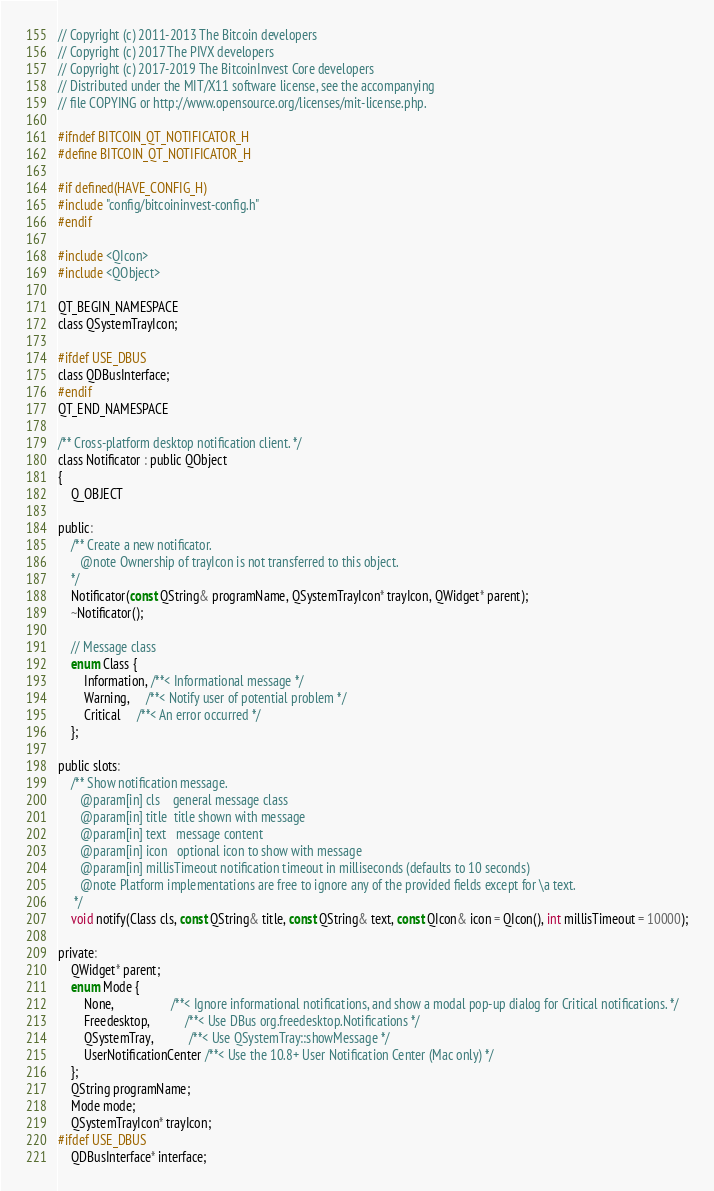Convert code to text. <code><loc_0><loc_0><loc_500><loc_500><_C_>// Copyright (c) 2011-2013 The Bitcoin developers
// Copyright (c) 2017 The PIVX developers
// Copyright (c) 2017-2019 The BitcoinInvest Core developers
// Distributed under the MIT/X11 software license, see the accompanying
// file COPYING or http://www.opensource.org/licenses/mit-license.php.

#ifndef BITCOIN_QT_NOTIFICATOR_H
#define BITCOIN_QT_NOTIFICATOR_H

#if defined(HAVE_CONFIG_H)
#include "config/bitcoininvest-config.h"
#endif

#include <QIcon>
#include <QObject>

QT_BEGIN_NAMESPACE
class QSystemTrayIcon;

#ifdef USE_DBUS
class QDBusInterface;
#endif
QT_END_NAMESPACE

/** Cross-platform desktop notification client. */
class Notificator : public QObject
{
    Q_OBJECT

public:
    /** Create a new notificator.
       @note Ownership of trayIcon is not transferred to this object.
    */
    Notificator(const QString& programName, QSystemTrayIcon* trayIcon, QWidget* parent);
    ~Notificator();

    // Message class
    enum Class {
        Information, /**< Informational message */
        Warning,     /**< Notify user of potential problem */
        Critical     /**< An error occurred */
    };

public slots:
    /** Show notification message.
       @param[in] cls    general message class
       @param[in] title  title shown with message
       @param[in] text   message content
       @param[in] icon   optional icon to show with message
       @param[in] millisTimeout notification timeout in milliseconds (defaults to 10 seconds)
       @note Platform implementations are free to ignore any of the provided fields except for \a text.
     */
    void notify(Class cls, const QString& title, const QString& text, const QIcon& icon = QIcon(), int millisTimeout = 10000);

private:
    QWidget* parent;
    enum Mode {
        None,                  /**< Ignore informational notifications, and show a modal pop-up dialog for Critical notifications. */
        Freedesktop,           /**< Use DBus org.freedesktop.Notifications */
        QSystemTray,           /**< Use QSystemTray::showMessage */
        UserNotificationCenter /**< Use the 10.8+ User Notification Center (Mac only) */
    };
    QString programName;
    Mode mode;
    QSystemTrayIcon* trayIcon;
#ifdef USE_DBUS
    QDBusInterface* interface;
</code> 